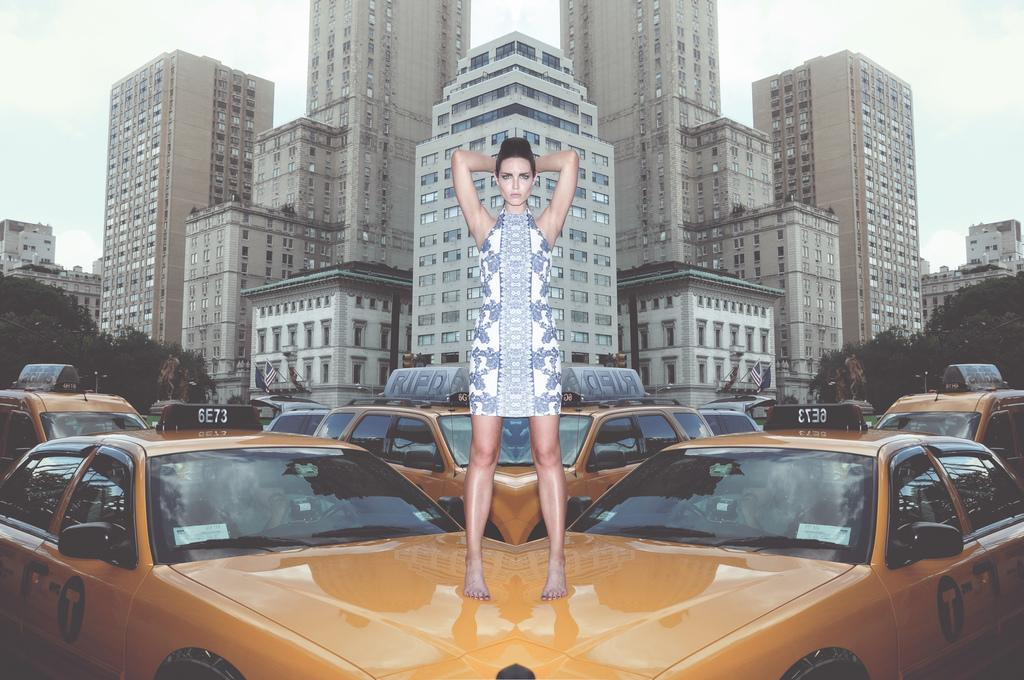Provide a one-sentence caption for the provided image. A barefoot woman stands on two taxi cabs that each have a large T on the door. 